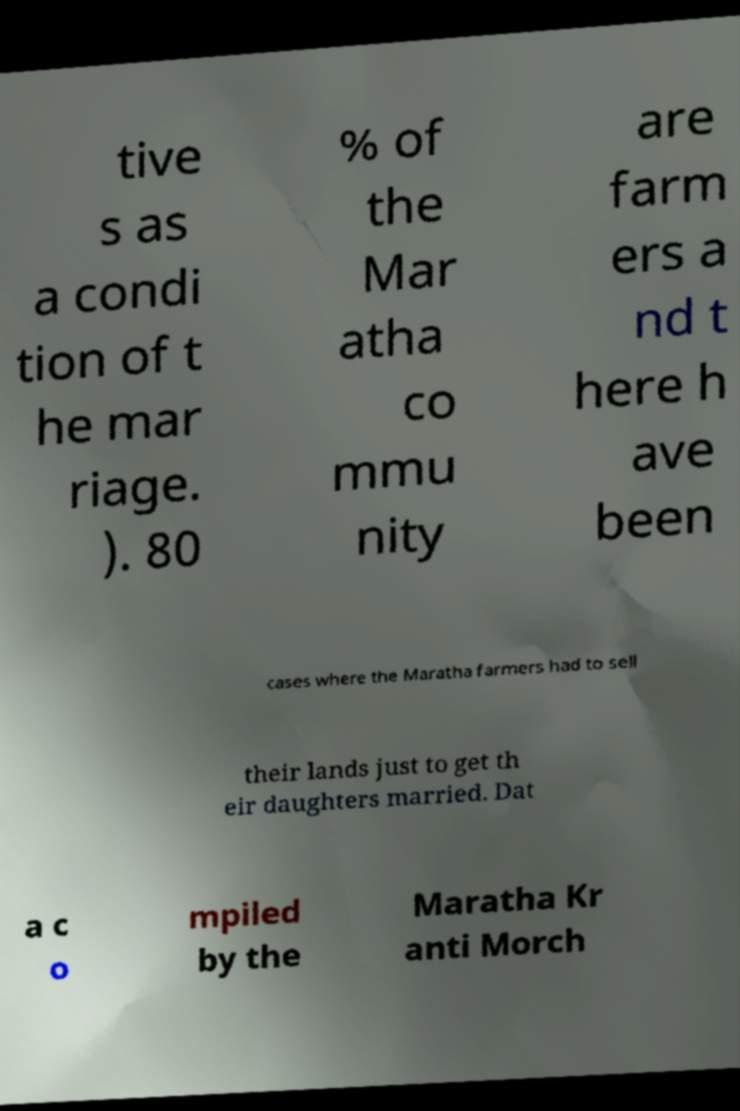Please identify and transcribe the text found in this image. tive s as a condi tion of t he mar riage. ). 80 % of the Mar atha co mmu nity are farm ers a nd t here h ave been cases where the Maratha farmers had to sell their lands just to get th eir daughters married. Dat a c o mpiled by the Maratha Kr anti Morch 